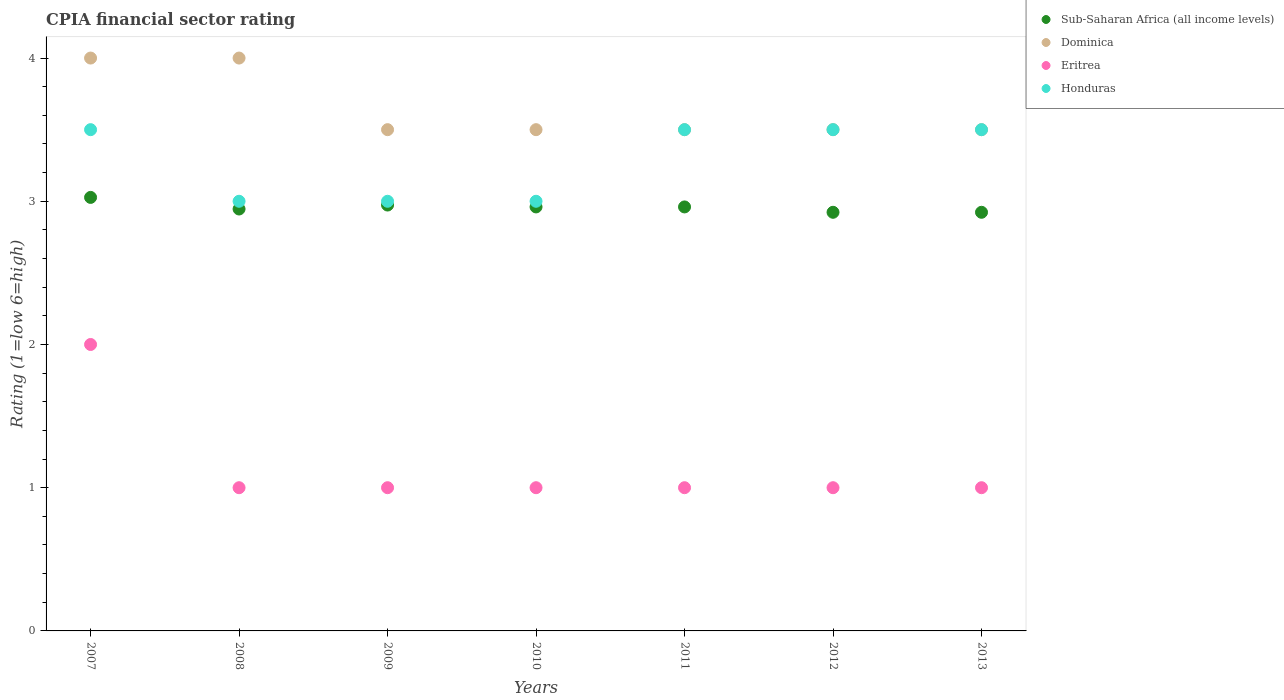How many different coloured dotlines are there?
Give a very brief answer. 4. What is the CPIA rating in Sub-Saharan Africa (all income levels) in 2007?
Your response must be concise. 3.03. Across all years, what is the maximum CPIA rating in Eritrea?
Your answer should be compact. 2. Across all years, what is the minimum CPIA rating in Honduras?
Your answer should be very brief. 3. What is the total CPIA rating in Eritrea in the graph?
Your answer should be compact. 8. What is the difference between the CPIA rating in Sub-Saharan Africa (all income levels) in 2008 and that in 2011?
Provide a succinct answer. -0.01. What is the difference between the CPIA rating in Sub-Saharan Africa (all income levels) in 2011 and the CPIA rating in Dominica in 2009?
Your answer should be very brief. -0.54. What is the average CPIA rating in Dominica per year?
Your response must be concise. 3.64. In how many years, is the CPIA rating in Eritrea greater than 2.6?
Offer a terse response. 0. What is the ratio of the CPIA rating in Sub-Saharan Africa (all income levels) in 2007 to that in 2008?
Provide a succinct answer. 1.03. Is the CPIA rating in Sub-Saharan Africa (all income levels) in 2009 less than that in 2010?
Your answer should be very brief. No. What is the difference between the highest and the second highest CPIA rating in Dominica?
Your answer should be very brief. 0. What is the difference between the highest and the lowest CPIA rating in Eritrea?
Make the answer very short. 1. Is the sum of the CPIA rating in Dominica in 2008 and 2009 greater than the maximum CPIA rating in Honduras across all years?
Give a very brief answer. Yes. Is it the case that in every year, the sum of the CPIA rating in Sub-Saharan Africa (all income levels) and CPIA rating in Honduras  is greater than the CPIA rating in Eritrea?
Offer a very short reply. Yes. Does the CPIA rating in Honduras monotonically increase over the years?
Your answer should be compact. No. Are the values on the major ticks of Y-axis written in scientific E-notation?
Give a very brief answer. No. Does the graph contain any zero values?
Keep it short and to the point. No. Where does the legend appear in the graph?
Your response must be concise. Top right. What is the title of the graph?
Ensure brevity in your answer.  CPIA financial sector rating. Does "Gambia, The" appear as one of the legend labels in the graph?
Your answer should be compact. No. What is the label or title of the X-axis?
Provide a succinct answer. Years. What is the label or title of the Y-axis?
Your response must be concise. Rating (1=low 6=high). What is the Rating (1=low 6=high) in Sub-Saharan Africa (all income levels) in 2007?
Offer a terse response. 3.03. What is the Rating (1=low 6=high) of Sub-Saharan Africa (all income levels) in 2008?
Offer a very short reply. 2.95. What is the Rating (1=low 6=high) in Eritrea in 2008?
Your answer should be compact. 1. What is the Rating (1=low 6=high) in Honduras in 2008?
Make the answer very short. 3. What is the Rating (1=low 6=high) of Sub-Saharan Africa (all income levels) in 2009?
Your answer should be very brief. 2.97. What is the Rating (1=low 6=high) of Dominica in 2009?
Your response must be concise. 3.5. What is the Rating (1=low 6=high) of Eritrea in 2009?
Provide a short and direct response. 1. What is the Rating (1=low 6=high) of Sub-Saharan Africa (all income levels) in 2010?
Offer a terse response. 2.96. What is the Rating (1=low 6=high) of Dominica in 2010?
Your response must be concise. 3.5. What is the Rating (1=low 6=high) of Eritrea in 2010?
Give a very brief answer. 1. What is the Rating (1=low 6=high) of Honduras in 2010?
Ensure brevity in your answer.  3. What is the Rating (1=low 6=high) in Sub-Saharan Africa (all income levels) in 2011?
Give a very brief answer. 2.96. What is the Rating (1=low 6=high) of Dominica in 2011?
Give a very brief answer. 3.5. What is the Rating (1=low 6=high) in Honduras in 2011?
Ensure brevity in your answer.  3.5. What is the Rating (1=low 6=high) in Sub-Saharan Africa (all income levels) in 2012?
Provide a short and direct response. 2.92. What is the Rating (1=low 6=high) of Dominica in 2012?
Ensure brevity in your answer.  3.5. What is the Rating (1=low 6=high) in Eritrea in 2012?
Your answer should be compact. 1. What is the Rating (1=low 6=high) in Sub-Saharan Africa (all income levels) in 2013?
Ensure brevity in your answer.  2.92. What is the Rating (1=low 6=high) in Dominica in 2013?
Your response must be concise. 3.5. What is the Rating (1=low 6=high) of Honduras in 2013?
Your answer should be compact. 3.5. Across all years, what is the maximum Rating (1=low 6=high) of Sub-Saharan Africa (all income levels)?
Provide a succinct answer. 3.03. Across all years, what is the maximum Rating (1=low 6=high) in Dominica?
Your response must be concise. 4. Across all years, what is the minimum Rating (1=low 6=high) of Sub-Saharan Africa (all income levels)?
Your answer should be compact. 2.92. Across all years, what is the minimum Rating (1=low 6=high) of Dominica?
Your answer should be very brief. 3.5. Across all years, what is the minimum Rating (1=low 6=high) of Honduras?
Make the answer very short. 3. What is the total Rating (1=low 6=high) of Sub-Saharan Africa (all income levels) in the graph?
Give a very brief answer. 20.71. What is the total Rating (1=low 6=high) in Dominica in the graph?
Give a very brief answer. 25.5. What is the total Rating (1=low 6=high) of Honduras in the graph?
Provide a succinct answer. 23. What is the difference between the Rating (1=low 6=high) in Sub-Saharan Africa (all income levels) in 2007 and that in 2008?
Provide a succinct answer. 0.08. What is the difference between the Rating (1=low 6=high) of Dominica in 2007 and that in 2008?
Provide a succinct answer. 0. What is the difference between the Rating (1=low 6=high) of Eritrea in 2007 and that in 2008?
Your answer should be very brief. 1. What is the difference between the Rating (1=low 6=high) in Honduras in 2007 and that in 2008?
Give a very brief answer. 0.5. What is the difference between the Rating (1=low 6=high) in Sub-Saharan Africa (all income levels) in 2007 and that in 2009?
Your response must be concise. 0.05. What is the difference between the Rating (1=low 6=high) of Dominica in 2007 and that in 2009?
Give a very brief answer. 0.5. What is the difference between the Rating (1=low 6=high) in Sub-Saharan Africa (all income levels) in 2007 and that in 2010?
Your answer should be compact. 0.07. What is the difference between the Rating (1=low 6=high) in Dominica in 2007 and that in 2010?
Provide a short and direct response. 0.5. What is the difference between the Rating (1=low 6=high) of Eritrea in 2007 and that in 2010?
Make the answer very short. 1. What is the difference between the Rating (1=low 6=high) of Honduras in 2007 and that in 2010?
Your response must be concise. 0.5. What is the difference between the Rating (1=low 6=high) of Sub-Saharan Africa (all income levels) in 2007 and that in 2011?
Make the answer very short. 0.07. What is the difference between the Rating (1=low 6=high) in Honduras in 2007 and that in 2011?
Your answer should be very brief. 0. What is the difference between the Rating (1=low 6=high) of Sub-Saharan Africa (all income levels) in 2007 and that in 2012?
Offer a terse response. 0.1. What is the difference between the Rating (1=low 6=high) in Sub-Saharan Africa (all income levels) in 2007 and that in 2013?
Provide a short and direct response. 0.1. What is the difference between the Rating (1=low 6=high) of Dominica in 2007 and that in 2013?
Offer a very short reply. 0.5. What is the difference between the Rating (1=low 6=high) of Honduras in 2007 and that in 2013?
Your answer should be compact. 0. What is the difference between the Rating (1=low 6=high) in Sub-Saharan Africa (all income levels) in 2008 and that in 2009?
Your response must be concise. -0.03. What is the difference between the Rating (1=low 6=high) in Eritrea in 2008 and that in 2009?
Your answer should be very brief. 0. What is the difference between the Rating (1=low 6=high) in Sub-Saharan Africa (all income levels) in 2008 and that in 2010?
Offer a very short reply. -0.01. What is the difference between the Rating (1=low 6=high) of Dominica in 2008 and that in 2010?
Provide a succinct answer. 0.5. What is the difference between the Rating (1=low 6=high) in Honduras in 2008 and that in 2010?
Your answer should be compact. 0. What is the difference between the Rating (1=low 6=high) in Sub-Saharan Africa (all income levels) in 2008 and that in 2011?
Offer a terse response. -0.01. What is the difference between the Rating (1=low 6=high) in Eritrea in 2008 and that in 2011?
Provide a short and direct response. 0. What is the difference between the Rating (1=low 6=high) of Sub-Saharan Africa (all income levels) in 2008 and that in 2012?
Your answer should be very brief. 0.02. What is the difference between the Rating (1=low 6=high) of Dominica in 2008 and that in 2012?
Keep it short and to the point. 0.5. What is the difference between the Rating (1=low 6=high) of Eritrea in 2008 and that in 2012?
Your answer should be compact. 0. What is the difference between the Rating (1=low 6=high) of Sub-Saharan Africa (all income levels) in 2008 and that in 2013?
Make the answer very short. 0.02. What is the difference between the Rating (1=low 6=high) of Dominica in 2008 and that in 2013?
Your response must be concise. 0.5. What is the difference between the Rating (1=low 6=high) in Sub-Saharan Africa (all income levels) in 2009 and that in 2010?
Provide a short and direct response. 0.01. What is the difference between the Rating (1=low 6=high) of Dominica in 2009 and that in 2010?
Your response must be concise. 0. What is the difference between the Rating (1=low 6=high) of Honduras in 2009 and that in 2010?
Give a very brief answer. 0. What is the difference between the Rating (1=low 6=high) of Sub-Saharan Africa (all income levels) in 2009 and that in 2011?
Provide a short and direct response. 0.01. What is the difference between the Rating (1=low 6=high) in Eritrea in 2009 and that in 2011?
Offer a very short reply. 0. What is the difference between the Rating (1=low 6=high) of Honduras in 2009 and that in 2011?
Offer a terse response. -0.5. What is the difference between the Rating (1=low 6=high) in Sub-Saharan Africa (all income levels) in 2009 and that in 2012?
Provide a short and direct response. 0.05. What is the difference between the Rating (1=low 6=high) of Dominica in 2009 and that in 2012?
Your answer should be compact. 0. What is the difference between the Rating (1=low 6=high) of Honduras in 2009 and that in 2012?
Give a very brief answer. -0.5. What is the difference between the Rating (1=low 6=high) of Sub-Saharan Africa (all income levels) in 2009 and that in 2013?
Keep it short and to the point. 0.05. What is the difference between the Rating (1=low 6=high) in Dominica in 2009 and that in 2013?
Provide a succinct answer. 0. What is the difference between the Rating (1=low 6=high) of Eritrea in 2009 and that in 2013?
Make the answer very short. 0. What is the difference between the Rating (1=low 6=high) of Dominica in 2010 and that in 2011?
Ensure brevity in your answer.  0. What is the difference between the Rating (1=low 6=high) of Honduras in 2010 and that in 2011?
Provide a succinct answer. -0.5. What is the difference between the Rating (1=low 6=high) in Sub-Saharan Africa (all income levels) in 2010 and that in 2012?
Make the answer very short. 0.04. What is the difference between the Rating (1=low 6=high) in Dominica in 2010 and that in 2012?
Your answer should be very brief. 0. What is the difference between the Rating (1=low 6=high) of Eritrea in 2010 and that in 2012?
Provide a succinct answer. 0. What is the difference between the Rating (1=low 6=high) in Sub-Saharan Africa (all income levels) in 2010 and that in 2013?
Your response must be concise. 0.04. What is the difference between the Rating (1=low 6=high) of Honduras in 2010 and that in 2013?
Your response must be concise. -0.5. What is the difference between the Rating (1=low 6=high) in Sub-Saharan Africa (all income levels) in 2011 and that in 2012?
Make the answer very short. 0.04. What is the difference between the Rating (1=low 6=high) of Sub-Saharan Africa (all income levels) in 2011 and that in 2013?
Give a very brief answer. 0.04. What is the difference between the Rating (1=low 6=high) in Eritrea in 2011 and that in 2013?
Your response must be concise. 0. What is the difference between the Rating (1=low 6=high) in Honduras in 2011 and that in 2013?
Offer a very short reply. 0. What is the difference between the Rating (1=low 6=high) in Eritrea in 2012 and that in 2013?
Your answer should be compact. 0. What is the difference between the Rating (1=low 6=high) of Honduras in 2012 and that in 2013?
Provide a succinct answer. 0. What is the difference between the Rating (1=low 6=high) of Sub-Saharan Africa (all income levels) in 2007 and the Rating (1=low 6=high) of Dominica in 2008?
Your response must be concise. -0.97. What is the difference between the Rating (1=low 6=high) in Sub-Saharan Africa (all income levels) in 2007 and the Rating (1=low 6=high) in Eritrea in 2008?
Provide a short and direct response. 2.03. What is the difference between the Rating (1=low 6=high) in Sub-Saharan Africa (all income levels) in 2007 and the Rating (1=low 6=high) in Honduras in 2008?
Make the answer very short. 0.03. What is the difference between the Rating (1=low 6=high) of Eritrea in 2007 and the Rating (1=low 6=high) of Honduras in 2008?
Make the answer very short. -1. What is the difference between the Rating (1=low 6=high) of Sub-Saharan Africa (all income levels) in 2007 and the Rating (1=low 6=high) of Dominica in 2009?
Make the answer very short. -0.47. What is the difference between the Rating (1=low 6=high) of Sub-Saharan Africa (all income levels) in 2007 and the Rating (1=low 6=high) of Eritrea in 2009?
Ensure brevity in your answer.  2.03. What is the difference between the Rating (1=low 6=high) in Sub-Saharan Africa (all income levels) in 2007 and the Rating (1=low 6=high) in Honduras in 2009?
Your answer should be very brief. 0.03. What is the difference between the Rating (1=low 6=high) of Dominica in 2007 and the Rating (1=low 6=high) of Eritrea in 2009?
Your response must be concise. 3. What is the difference between the Rating (1=low 6=high) of Dominica in 2007 and the Rating (1=low 6=high) of Honduras in 2009?
Keep it short and to the point. 1. What is the difference between the Rating (1=low 6=high) of Sub-Saharan Africa (all income levels) in 2007 and the Rating (1=low 6=high) of Dominica in 2010?
Keep it short and to the point. -0.47. What is the difference between the Rating (1=low 6=high) in Sub-Saharan Africa (all income levels) in 2007 and the Rating (1=low 6=high) in Eritrea in 2010?
Provide a succinct answer. 2.03. What is the difference between the Rating (1=low 6=high) of Sub-Saharan Africa (all income levels) in 2007 and the Rating (1=low 6=high) of Honduras in 2010?
Offer a very short reply. 0.03. What is the difference between the Rating (1=low 6=high) in Eritrea in 2007 and the Rating (1=low 6=high) in Honduras in 2010?
Keep it short and to the point. -1. What is the difference between the Rating (1=low 6=high) of Sub-Saharan Africa (all income levels) in 2007 and the Rating (1=low 6=high) of Dominica in 2011?
Your answer should be compact. -0.47. What is the difference between the Rating (1=low 6=high) of Sub-Saharan Africa (all income levels) in 2007 and the Rating (1=low 6=high) of Eritrea in 2011?
Make the answer very short. 2.03. What is the difference between the Rating (1=low 6=high) of Sub-Saharan Africa (all income levels) in 2007 and the Rating (1=low 6=high) of Honduras in 2011?
Provide a short and direct response. -0.47. What is the difference between the Rating (1=low 6=high) in Sub-Saharan Africa (all income levels) in 2007 and the Rating (1=low 6=high) in Dominica in 2012?
Offer a very short reply. -0.47. What is the difference between the Rating (1=low 6=high) in Sub-Saharan Africa (all income levels) in 2007 and the Rating (1=low 6=high) in Eritrea in 2012?
Ensure brevity in your answer.  2.03. What is the difference between the Rating (1=low 6=high) of Sub-Saharan Africa (all income levels) in 2007 and the Rating (1=low 6=high) of Honduras in 2012?
Your answer should be very brief. -0.47. What is the difference between the Rating (1=low 6=high) in Dominica in 2007 and the Rating (1=low 6=high) in Honduras in 2012?
Provide a succinct answer. 0.5. What is the difference between the Rating (1=low 6=high) of Eritrea in 2007 and the Rating (1=low 6=high) of Honduras in 2012?
Offer a very short reply. -1.5. What is the difference between the Rating (1=low 6=high) of Sub-Saharan Africa (all income levels) in 2007 and the Rating (1=low 6=high) of Dominica in 2013?
Ensure brevity in your answer.  -0.47. What is the difference between the Rating (1=low 6=high) of Sub-Saharan Africa (all income levels) in 2007 and the Rating (1=low 6=high) of Eritrea in 2013?
Your answer should be compact. 2.03. What is the difference between the Rating (1=low 6=high) in Sub-Saharan Africa (all income levels) in 2007 and the Rating (1=low 6=high) in Honduras in 2013?
Keep it short and to the point. -0.47. What is the difference between the Rating (1=low 6=high) in Dominica in 2007 and the Rating (1=low 6=high) in Honduras in 2013?
Ensure brevity in your answer.  0.5. What is the difference between the Rating (1=low 6=high) in Eritrea in 2007 and the Rating (1=low 6=high) in Honduras in 2013?
Offer a terse response. -1.5. What is the difference between the Rating (1=low 6=high) in Sub-Saharan Africa (all income levels) in 2008 and the Rating (1=low 6=high) in Dominica in 2009?
Your answer should be compact. -0.55. What is the difference between the Rating (1=low 6=high) in Sub-Saharan Africa (all income levels) in 2008 and the Rating (1=low 6=high) in Eritrea in 2009?
Your response must be concise. 1.95. What is the difference between the Rating (1=low 6=high) in Sub-Saharan Africa (all income levels) in 2008 and the Rating (1=low 6=high) in Honduras in 2009?
Give a very brief answer. -0.05. What is the difference between the Rating (1=low 6=high) in Sub-Saharan Africa (all income levels) in 2008 and the Rating (1=low 6=high) in Dominica in 2010?
Offer a terse response. -0.55. What is the difference between the Rating (1=low 6=high) in Sub-Saharan Africa (all income levels) in 2008 and the Rating (1=low 6=high) in Eritrea in 2010?
Ensure brevity in your answer.  1.95. What is the difference between the Rating (1=low 6=high) of Sub-Saharan Africa (all income levels) in 2008 and the Rating (1=low 6=high) of Honduras in 2010?
Ensure brevity in your answer.  -0.05. What is the difference between the Rating (1=low 6=high) in Dominica in 2008 and the Rating (1=low 6=high) in Honduras in 2010?
Provide a short and direct response. 1. What is the difference between the Rating (1=low 6=high) of Sub-Saharan Africa (all income levels) in 2008 and the Rating (1=low 6=high) of Dominica in 2011?
Your response must be concise. -0.55. What is the difference between the Rating (1=low 6=high) of Sub-Saharan Africa (all income levels) in 2008 and the Rating (1=low 6=high) of Eritrea in 2011?
Give a very brief answer. 1.95. What is the difference between the Rating (1=low 6=high) of Sub-Saharan Africa (all income levels) in 2008 and the Rating (1=low 6=high) of Honduras in 2011?
Provide a succinct answer. -0.55. What is the difference between the Rating (1=low 6=high) of Dominica in 2008 and the Rating (1=low 6=high) of Eritrea in 2011?
Give a very brief answer. 3. What is the difference between the Rating (1=low 6=high) in Sub-Saharan Africa (all income levels) in 2008 and the Rating (1=low 6=high) in Dominica in 2012?
Offer a very short reply. -0.55. What is the difference between the Rating (1=low 6=high) of Sub-Saharan Africa (all income levels) in 2008 and the Rating (1=low 6=high) of Eritrea in 2012?
Offer a very short reply. 1.95. What is the difference between the Rating (1=low 6=high) in Sub-Saharan Africa (all income levels) in 2008 and the Rating (1=low 6=high) in Honduras in 2012?
Offer a very short reply. -0.55. What is the difference between the Rating (1=low 6=high) of Dominica in 2008 and the Rating (1=low 6=high) of Honduras in 2012?
Your answer should be compact. 0.5. What is the difference between the Rating (1=low 6=high) of Eritrea in 2008 and the Rating (1=low 6=high) of Honduras in 2012?
Keep it short and to the point. -2.5. What is the difference between the Rating (1=low 6=high) of Sub-Saharan Africa (all income levels) in 2008 and the Rating (1=low 6=high) of Dominica in 2013?
Ensure brevity in your answer.  -0.55. What is the difference between the Rating (1=low 6=high) in Sub-Saharan Africa (all income levels) in 2008 and the Rating (1=low 6=high) in Eritrea in 2013?
Give a very brief answer. 1.95. What is the difference between the Rating (1=low 6=high) of Sub-Saharan Africa (all income levels) in 2008 and the Rating (1=low 6=high) of Honduras in 2013?
Give a very brief answer. -0.55. What is the difference between the Rating (1=low 6=high) of Eritrea in 2008 and the Rating (1=low 6=high) of Honduras in 2013?
Offer a terse response. -2.5. What is the difference between the Rating (1=low 6=high) of Sub-Saharan Africa (all income levels) in 2009 and the Rating (1=low 6=high) of Dominica in 2010?
Make the answer very short. -0.53. What is the difference between the Rating (1=low 6=high) in Sub-Saharan Africa (all income levels) in 2009 and the Rating (1=low 6=high) in Eritrea in 2010?
Offer a very short reply. 1.97. What is the difference between the Rating (1=low 6=high) in Sub-Saharan Africa (all income levels) in 2009 and the Rating (1=low 6=high) in Honduras in 2010?
Your answer should be very brief. -0.03. What is the difference between the Rating (1=low 6=high) of Sub-Saharan Africa (all income levels) in 2009 and the Rating (1=low 6=high) of Dominica in 2011?
Keep it short and to the point. -0.53. What is the difference between the Rating (1=low 6=high) of Sub-Saharan Africa (all income levels) in 2009 and the Rating (1=low 6=high) of Eritrea in 2011?
Provide a short and direct response. 1.97. What is the difference between the Rating (1=low 6=high) of Sub-Saharan Africa (all income levels) in 2009 and the Rating (1=low 6=high) of Honduras in 2011?
Your answer should be very brief. -0.53. What is the difference between the Rating (1=low 6=high) of Dominica in 2009 and the Rating (1=low 6=high) of Eritrea in 2011?
Your response must be concise. 2.5. What is the difference between the Rating (1=low 6=high) of Sub-Saharan Africa (all income levels) in 2009 and the Rating (1=low 6=high) of Dominica in 2012?
Make the answer very short. -0.53. What is the difference between the Rating (1=low 6=high) of Sub-Saharan Africa (all income levels) in 2009 and the Rating (1=low 6=high) of Eritrea in 2012?
Make the answer very short. 1.97. What is the difference between the Rating (1=low 6=high) in Sub-Saharan Africa (all income levels) in 2009 and the Rating (1=low 6=high) in Honduras in 2012?
Your answer should be compact. -0.53. What is the difference between the Rating (1=low 6=high) in Dominica in 2009 and the Rating (1=low 6=high) in Eritrea in 2012?
Keep it short and to the point. 2.5. What is the difference between the Rating (1=low 6=high) of Dominica in 2009 and the Rating (1=low 6=high) of Honduras in 2012?
Offer a very short reply. 0. What is the difference between the Rating (1=low 6=high) of Sub-Saharan Africa (all income levels) in 2009 and the Rating (1=low 6=high) of Dominica in 2013?
Your answer should be very brief. -0.53. What is the difference between the Rating (1=low 6=high) in Sub-Saharan Africa (all income levels) in 2009 and the Rating (1=low 6=high) in Eritrea in 2013?
Keep it short and to the point. 1.97. What is the difference between the Rating (1=low 6=high) of Sub-Saharan Africa (all income levels) in 2009 and the Rating (1=low 6=high) of Honduras in 2013?
Your answer should be compact. -0.53. What is the difference between the Rating (1=low 6=high) in Dominica in 2009 and the Rating (1=low 6=high) in Eritrea in 2013?
Provide a succinct answer. 2.5. What is the difference between the Rating (1=low 6=high) in Sub-Saharan Africa (all income levels) in 2010 and the Rating (1=low 6=high) in Dominica in 2011?
Keep it short and to the point. -0.54. What is the difference between the Rating (1=low 6=high) in Sub-Saharan Africa (all income levels) in 2010 and the Rating (1=low 6=high) in Eritrea in 2011?
Provide a succinct answer. 1.96. What is the difference between the Rating (1=low 6=high) in Sub-Saharan Africa (all income levels) in 2010 and the Rating (1=low 6=high) in Honduras in 2011?
Provide a short and direct response. -0.54. What is the difference between the Rating (1=low 6=high) of Dominica in 2010 and the Rating (1=low 6=high) of Eritrea in 2011?
Ensure brevity in your answer.  2.5. What is the difference between the Rating (1=low 6=high) in Dominica in 2010 and the Rating (1=low 6=high) in Honduras in 2011?
Make the answer very short. 0. What is the difference between the Rating (1=low 6=high) of Sub-Saharan Africa (all income levels) in 2010 and the Rating (1=low 6=high) of Dominica in 2012?
Offer a terse response. -0.54. What is the difference between the Rating (1=low 6=high) in Sub-Saharan Africa (all income levels) in 2010 and the Rating (1=low 6=high) in Eritrea in 2012?
Your answer should be compact. 1.96. What is the difference between the Rating (1=low 6=high) in Sub-Saharan Africa (all income levels) in 2010 and the Rating (1=low 6=high) in Honduras in 2012?
Your answer should be very brief. -0.54. What is the difference between the Rating (1=low 6=high) of Dominica in 2010 and the Rating (1=low 6=high) of Eritrea in 2012?
Your answer should be very brief. 2.5. What is the difference between the Rating (1=low 6=high) of Sub-Saharan Africa (all income levels) in 2010 and the Rating (1=low 6=high) of Dominica in 2013?
Give a very brief answer. -0.54. What is the difference between the Rating (1=low 6=high) in Sub-Saharan Africa (all income levels) in 2010 and the Rating (1=low 6=high) in Eritrea in 2013?
Provide a short and direct response. 1.96. What is the difference between the Rating (1=low 6=high) in Sub-Saharan Africa (all income levels) in 2010 and the Rating (1=low 6=high) in Honduras in 2013?
Provide a short and direct response. -0.54. What is the difference between the Rating (1=low 6=high) of Dominica in 2010 and the Rating (1=low 6=high) of Honduras in 2013?
Your answer should be compact. 0. What is the difference between the Rating (1=low 6=high) in Eritrea in 2010 and the Rating (1=low 6=high) in Honduras in 2013?
Provide a short and direct response. -2.5. What is the difference between the Rating (1=low 6=high) of Sub-Saharan Africa (all income levels) in 2011 and the Rating (1=low 6=high) of Dominica in 2012?
Give a very brief answer. -0.54. What is the difference between the Rating (1=low 6=high) of Sub-Saharan Africa (all income levels) in 2011 and the Rating (1=low 6=high) of Eritrea in 2012?
Make the answer very short. 1.96. What is the difference between the Rating (1=low 6=high) of Sub-Saharan Africa (all income levels) in 2011 and the Rating (1=low 6=high) of Honduras in 2012?
Your answer should be compact. -0.54. What is the difference between the Rating (1=low 6=high) of Dominica in 2011 and the Rating (1=low 6=high) of Honduras in 2012?
Keep it short and to the point. 0. What is the difference between the Rating (1=low 6=high) of Eritrea in 2011 and the Rating (1=low 6=high) of Honduras in 2012?
Keep it short and to the point. -2.5. What is the difference between the Rating (1=low 6=high) of Sub-Saharan Africa (all income levels) in 2011 and the Rating (1=low 6=high) of Dominica in 2013?
Offer a very short reply. -0.54. What is the difference between the Rating (1=low 6=high) of Sub-Saharan Africa (all income levels) in 2011 and the Rating (1=low 6=high) of Eritrea in 2013?
Offer a very short reply. 1.96. What is the difference between the Rating (1=low 6=high) of Sub-Saharan Africa (all income levels) in 2011 and the Rating (1=low 6=high) of Honduras in 2013?
Offer a terse response. -0.54. What is the difference between the Rating (1=low 6=high) in Dominica in 2011 and the Rating (1=low 6=high) in Eritrea in 2013?
Provide a succinct answer. 2.5. What is the difference between the Rating (1=low 6=high) in Dominica in 2011 and the Rating (1=low 6=high) in Honduras in 2013?
Offer a terse response. 0. What is the difference between the Rating (1=low 6=high) of Sub-Saharan Africa (all income levels) in 2012 and the Rating (1=low 6=high) of Dominica in 2013?
Provide a short and direct response. -0.58. What is the difference between the Rating (1=low 6=high) of Sub-Saharan Africa (all income levels) in 2012 and the Rating (1=low 6=high) of Eritrea in 2013?
Your response must be concise. 1.92. What is the difference between the Rating (1=low 6=high) in Sub-Saharan Africa (all income levels) in 2012 and the Rating (1=low 6=high) in Honduras in 2013?
Provide a succinct answer. -0.58. What is the difference between the Rating (1=low 6=high) of Dominica in 2012 and the Rating (1=low 6=high) of Honduras in 2013?
Make the answer very short. 0. What is the difference between the Rating (1=low 6=high) of Eritrea in 2012 and the Rating (1=low 6=high) of Honduras in 2013?
Your answer should be very brief. -2.5. What is the average Rating (1=low 6=high) in Sub-Saharan Africa (all income levels) per year?
Your answer should be very brief. 2.96. What is the average Rating (1=low 6=high) in Dominica per year?
Offer a very short reply. 3.64. What is the average Rating (1=low 6=high) of Eritrea per year?
Ensure brevity in your answer.  1.14. What is the average Rating (1=low 6=high) of Honduras per year?
Make the answer very short. 3.29. In the year 2007, what is the difference between the Rating (1=low 6=high) of Sub-Saharan Africa (all income levels) and Rating (1=low 6=high) of Dominica?
Offer a very short reply. -0.97. In the year 2007, what is the difference between the Rating (1=low 6=high) of Sub-Saharan Africa (all income levels) and Rating (1=low 6=high) of Honduras?
Your answer should be very brief. -0.47. In the year 2007, what is the difference between the Rating (1=low 6=high) in Dominica and Rating (1=low 6=high) in Eritrea?
Ensure brevity in your answer.  2. In the year 2007, what is the difference between the Rating (1=low 6=high) of Eritrea and Rating (1=low 6=high) of Honduras?
Your response must be concise. -1.5. In the year 2008, what is the difference between the Rating (1=low 6=high) in Sub-Saharan Africa (all income levels) and Rating (1=low 6=high) in Dominica?
Your answer should be very brief. -1.05. In the year 2008, what is the difference between the Rating (1=low 6=high) of Sub-Saharan Africa (all income levels) and Rating (1=low 6=high) of Eritrea?
Give a very brief answer. 1.95. In the year 2008, what is the difference between the Rating (1=low 6=high) of Sub-Saharan Africa (all income levels) and Rating (1=low 6=high) of Honduras?
Make the answer very short. -0.05. In the year 2009, what is the difference between the Rating (1=low 6=high) of Sub-Saharan Africa (all income levels) and Rating (1=low 6=high) of Dominica?
Your response must be concise. -0.53. In the year 2009, what is the difference between the Rating (1=low 6=high) of Sub-Saharan Africa (all income levels) and Rating (1=low 6=high) of Eritrea?
Provide a short and direct response. 1.97. In the year 2009, what is the difference between the Rating (1=low 6=high) of Sub-Saharan Africa (all income levels) and Rating (1=low 6=high) of Honduras?
Give a very brief answer. -0.03. In the year 2010, what is the difference between the Rating (1=low 6=high) of Sub-Saharan Africa (all income levels) and Rating (1=low 6=high) of Dominica?
Provide a short and direct response. -0.54. In the year 2010, what is the difference between the Rating (1=low 6=high) in Sub-Saharan Africa (all income levels) and Rating (1=low 6=high) in Eritrea?
Your answer should be compact. 1.96. In the year 2010, what is the difference between the Rating (1=low 6=high) of Sub-Saharan Africa (all income levels) and Rating (1=low 6=high) of Honduras?
Ensure brevity in your answer.  -0.04. In the year 2011, what is the difference between the Rating (1=low 6=high) of Sub-Saharan Africa (all income levels) and Rating (1=low 6=high) of Dominica?
Make the answer very short. -0.54. In the year 2011, what is the difference between the Rating (1=low 6=high) of Sub-Saharan Africa (all income levels) and Rating (1=low 6=high) of Eritrea?
Your answer should be compact. 1.96. In the year 2011, what is the difference between the Rating (1=low 6=high) in Sub-Saharan Africa (all income levels) and Rating (1=low 6=high) in Honduras?
Ensure brevity in your answer.  -0.54. In the year 2011, what is the difference between the Rating (1=low 6=high) of Dominica and Rating (1=low 6=high) of Eritrea?
Your response must be concise. 2.5. In the year 2012, what is the difference between the Rating (1=low 6=high) of Sub-Saharan Africa (all income levels) and Rating (1=low 6=high) of Dominica?
Your response must be concise. -0.58. In the year 2012, what is the difference between the Rating (1=low 6=high) in Sub-Saharan Africa (all income levels) and Rating (1=low 6=high) in Eritrea?
Provide a succinct answer. 1.92. In the year 2012, what is the difference between the Rating (1=low 6=high) in Sub-Saharan Africa (all income levels) and Rating (1=low 6=high) in Honduras?
Make the answer very short. -0.58. In the year 2012, what is the difference between the Rating (1=low 6=high) in Dominica and Rating (1=low 6=high) in Eritrea?
Keep it short and to the point. 2.5. In the year 2012, what is the difference between the Rating (1=low 6=high) of Dominica and Rating (1=low 6=high) of Honduras?
Make the answer very short. 0. In the year 2013, what is the difference between the Rating (1=low 6=high) in Sub-Saharan Africa (all income levels) and Rating (1=low 6=high) in Dominica?
Ensure brevity in your answer.  -0.58. In the year 2013, what is the difference between the Rating (1=low 6=high) in Sub-Saharan Africa (all income levels) and Rating (1=low 6=high) in Eritrea?
Give a very brief answer. 1.92. In the year 2013, what is the difference between the Rating (1=low 6=high) in Sub-Saharan Africa (all income levels) and Rating (1=low 6=high) in Honduras?
Your answer should be compact. -0.58. What is the ratio of the Rating (1=low 6=high) of Sub-Saharan Africa (all income levels) in 2007 to that in 2008?
Provide a short and direct response. 1.03. What is the ratio of the Rating (1=low 6=high) in Dominica in 2007 to that in 2008?
Ensure brevity in your answer.  1. What is the ratio of the Rating (1=low 6=high) in Eritrea in 2007 to that in 2008?
Provide a short and direct response. 2. What is the ratio of the Rating (1=low 6=high) of Honduras in 2007 to that in 2008?
Your response must be concise. 1.17. What is the ratio of the Rating (1=low 6=high) in Sub-Saharan Africa (all income levels) in 2007 to that in 2009?
Offer a very short reply. 1.02. What is the ratio of the Rating (1=low 6=high) of Eritrea in 2007 to that in 2009?
Offer a terse response. 2. What is the ratio of the Rating (1=low 6=high) of Sub-Saharan Africa (all income levels) in 2007 to that in 2010?
Give a very brief answer. 1.02. What is the ratio of the Rating (1=low 6=high) in Eritrea in 2007 to that in 2010?
Your answer should be very brief. 2. What is the ratio of the Rating (1=low 6=high) in Honduras in 2007 to that in 2010?
Keep it short and to the point. 1.17. What is the ratio of the Rating (1=low 6=high) of Sub-Saharan Africa (all income levels) in 2007 to that in 2011?
Ensure brevity in your answer.  1.02. What is the ratio of the Rating (1=low 6=high) in Dominica in 2007 to that in 2011?
Offer a very short reply. 1.14. What is the ratio of the Rating (1=low 6=high) in Eritrea in 2007 to that in 2011?
Offer a very short reply. 2. What is the ratio of the Rating (1=low 6=high) in Honduras in 2007 to that in 2011?
Give a very brief answer. 1. What is the ratio of the Rating (1=low 6=high) in Sub-Saharan Africa (all income levels) in 2007 to that in 2012?
Ensure brevity in your answer.  1.04. What is the ratio of the Rating (1=low 6=high) of Dominica in 2007 to that in 2012?
Your response must be concise. 1.14. What is the ratio of the Rating (1=low 6=high) of Honduras in 2007 to that in 2012?
Offer a very short reply. 1. What is the ratio of the Rating (1=low 6=high) in Sub-Saharan Africa (all income levels) in 2007 to that in 2013?
Make the answer very short. 1.04. What is the ratio of the Rating (1=low 6=high) of Honduras in 2007 to that in 2013?
Your answer should be compact. 1. What is the ratio of the Rating (1=low 6=high) of Sub-Saharan Africa (all income levels) in 2008 to that in 2009?
Your answer should be compact. 0.99. What is the ratio of the Rating (1=low 6=high) of Eritrea in 2008 to that in 2009?
Make the answer very short. 1. What is the ratio of the Rating (1=low 6=high) of Honduras in 2008 to that in 2009?
Provide a short and direct response. 1. What is the ratio of the Rating (1=low 6=high) in Dominica in 2008 to that in 2010?
Provide a succinct answer. 1.14. What is the ratio of the Rating (1=low 6=high) of Eritrea in 2008 to that in 2010?
Offer a terse response. 1. What is the ratio of the Rating (1=low 6=high) of Dominica in 2008 to that in 2011?
Make the answer very short. 1.14. What is the ratio of the Rating (1=low 6=high) in Sub-Saharan Africa (all income levels) in 2008 to that in 2012?
Give a very brief answer. 1.01. What is the ratio of the Rating (1=low 6=high) of Dominica in 2008 to that in 2012?
Give a very brief answer. 1.14. What is the ratio of the Rating (1=low 6=high) in Eritrea in 2008 to that in 2012?
Your response must be concise. 1. What is the ratio of the Rating (1=low 6=high) of Sub-Saharan Africa (all income levels) in 2008 to that in 2013?
Your response must be concise. 1.01. What is the ratio of the Rating (1=low 6=high) of Dominica in 2008 to that in 2013?
Your answer should be compact. 1.14. What is the ratio of the Rating (1=low 6=high) of Honduras in 2008 to that in 2013?
Your answer should be compact. 0.86. What is the ratio of the Rating (1=low 6=high) of Dominica in 2009 to that in 2010?
Keep it short and to the point. 1. What is the ratio of the Rating (1=low 6=high) of Eritrea in 2009 to that in 2010?
Give a very brief answer. 1. What is the ratio of the Rating (1=low 6=high) of Honduras in 2009 to that in 2010?
Provide a short and direct response. 1. What is the ratio of the Rating (1=low 6=high) in Sub-Saharan Africa (all income levels) in 2009 to that in 2011?
Offer a terse response. 1. What is the ratio of the Rating (1=low 6=high) in Sub-Saharan Africa (all income levels) in 2009 to that in 2012?
Your answer should be very brief. 1.02. What is the ratio of the Rating (1=low 6=high) in Eritrea in 2009 to that in 2012?
Give a very brief answer. 1. What is the ratio of the Rating (1=low 6=high) in Honduras in 2009 to that in 2012?
Your answer should be compact. 0.86. What is the ratio of the Rating (1=low 6=high) in Sub-Saharan Africa (all income levels) in 2009 to that in 2013?
Offer a terse response. 1.02. What is the ratio of the Rating (1=low 6=high) of Dominica in 2009 to that in 2013?
Your answer should be compact. 1. What is the ratio of the Rating (1=low 6=high) of Eritrea in 2009 to that in 2013?
Ensure brevity in your answer.  1. What is the ratio of the Rating (1=low 6=high) in Sub-Saharan Africa (all income levels) in 2010 to that in 2011?
Make the answer very short. 1. What is the ratio of the Rating (1=low 6=high) of Eritrea in 2010 to that in 2011?
Offer a very short reply. 1. What is the ratio of the Rating (1=low 6=high) of Honduras in 2010 to that in 2011?
Provide a succinct answer. 0.86. What is the ratio of the Rating (1=low 6=high) of Sub-Saharan Africa (all income levels) in 2010 to that in 2012?
Ensure brevity in your answer.  1.01. What is the ratio of the Rating (1=low 6=high) in Dominica in 2010 to that in 2012?
Provide a succinct answer. 1. What is the ratio of the Rating (1=low 6=high) of Eritrea in 2010 to that in 2012?
Provide a short and direct response. 1. What is the ratio of the Rating (1=low 6=high) in Sub-Saharan Africa (all income levels) in 2010 to that in 2013?
Provide a short and direct response. 1.01. What is the ratio of the Rating (1=low 6=high) of Dominica in 2010 to that in 2013?
Give a very brief answer. 1. What is the ratio of the Rating (1=low 6=high) in Sub-Saharan Africa (all income levels) in 2011 to that in 2012?
Your answer should be compact. 1.01. What is the ratio of the Rating (1=low 6=high) of Dominica in 2011 to that in 2012?
Ensure brevity in your answer.  1. What is the ratio of the Rating (1=low 6=high) of Eritrea in 2011 to that in 2012?
Offer a very short reply. 1. What is the ratio of the Rating (1=low 6=high) of Honduras in 2011 to that in 2012?
Your answer should be compact. 1. What is the ratio of the Rating (1=low 6=high) in Sub-Saharan Africa (all income levels) in 2011 to that in 2013?
Your answer should be compact. 1.01. What is the ratio of the Rating (1=low 6=high) in Dominica in 2011 to that in 2013?
Provide a succinct answer. 1. What is the ratio of the Rating (1=low 6=high) in Sub-Saharan Africa (all income levels) in 2012 to that in 2013?
Keep it short and to the point. 1. What is the ratio of the Rating (1=low 6=high) in Honduras in 2012 to that in 2013?
Provide a succinct answer. 1. What is the difference between the highest and the second highest Rating (1=low 6=high) in Sub-Saharan Africa (all income levels)?
Ensure brevity in your answer.  0.05. What is the difference between the highest and the second highest Rating (1=low 6=high) of Dominica?
Offer a terse response. 0. What is the difference between the highest and the lowest Rating (1=low 6=high) of Sub-Saharan Africa (all income levels)?
Provide a succinct answer. 0.1. 